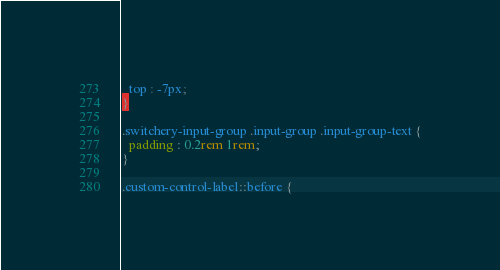Convert code to text. <code><loc_0><loc_0><loc_500><loc_500><_CSS_>  top : -7px;
}

.switchery-input-group .input-group .input-group-text {
  padding : 0.2rem 1rem;
}

.custom-control-label::before {</code> 